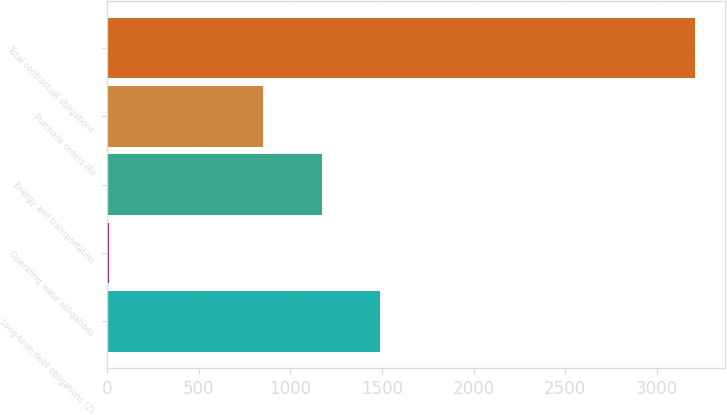Convert chart to OTSL. <chart><loc_0><loc_0><loc_500><loc_500><bar_chart><fcel>Long-term debt obligations (2)<fcel>Operating lease obligations<fcel>Energy and transportation<fcel>Purchase orders (6)<fcel>Total contractual obligations<nl><fcel>1491.56<fcel>9.5<fcel>1171.43<fcel>851.3<fcel>3210.8<nl></chart> 